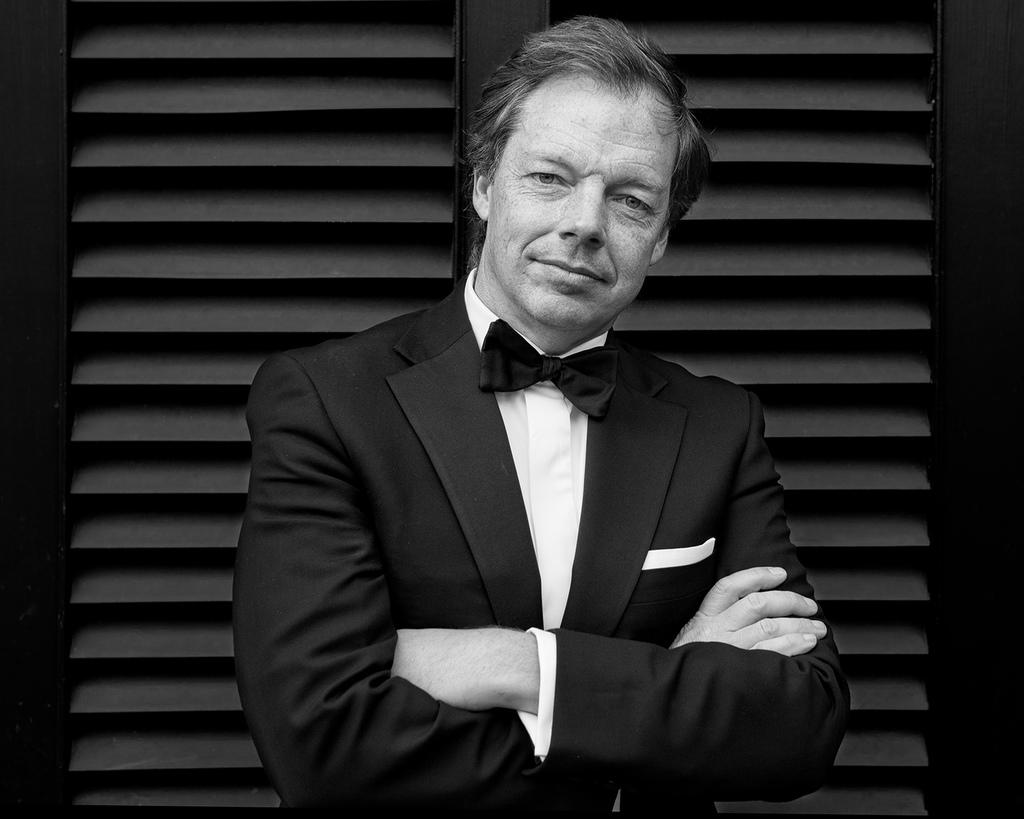What is the color scheme of the image? The image is black and white. Who is present in the image? There is a man in the image. What is the man doing in the image? The man is standing and folding his hands. What can be seen in the background of the image? There is a door in the background of the image. What type of stew is being prepared in the image? There is no stew present in the image; it is a black and white image of a man standing and folding his hands. Can you tell me how many horses are visible in the image? There are no horses present in the image. 